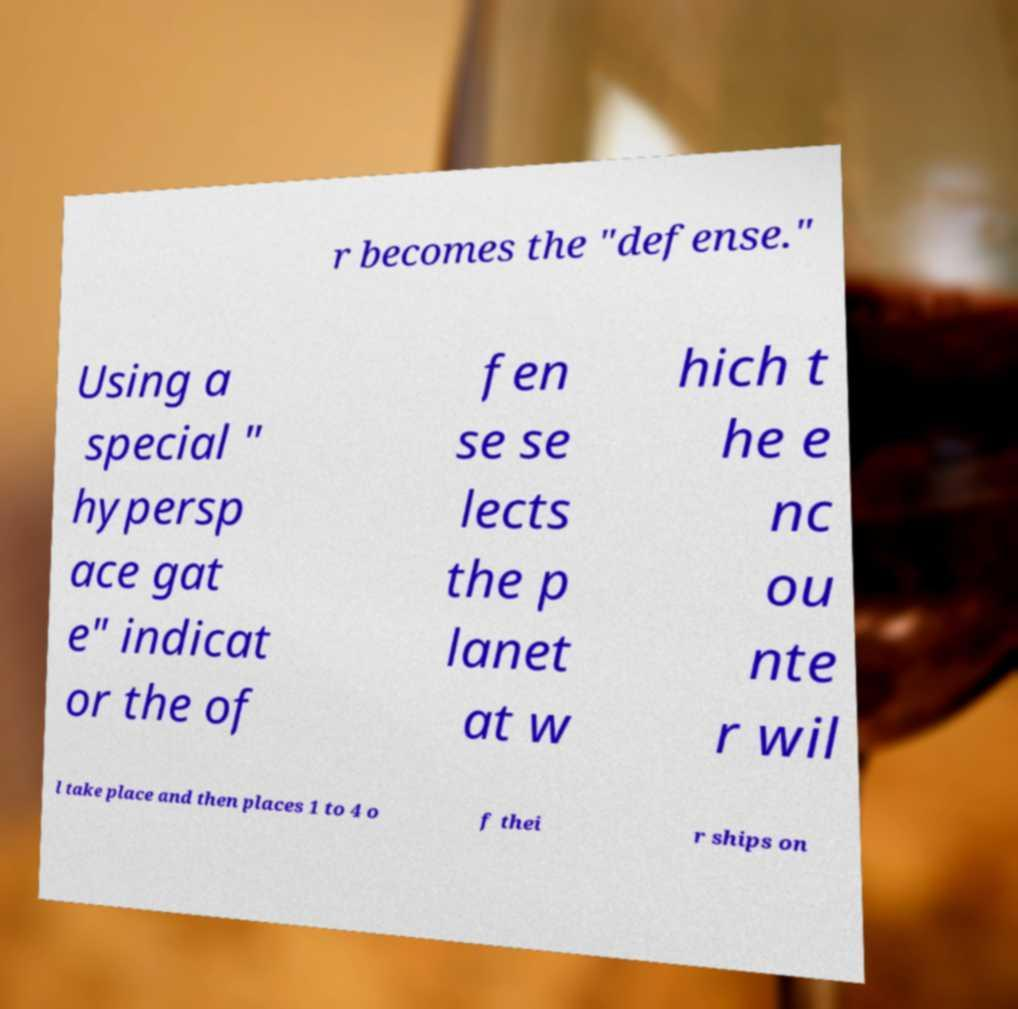Can you read and provide the text displayed in the image?This photo seems to have some interesting text. Can you extract and type it out for me? r becomes the "defense." Using a special " hypersp ace gat e" indicat or the of fen se se lects the p lanet at w hich t he e nc ou nte r wil l take place and then places 1 to 4 o f thei r ships on 